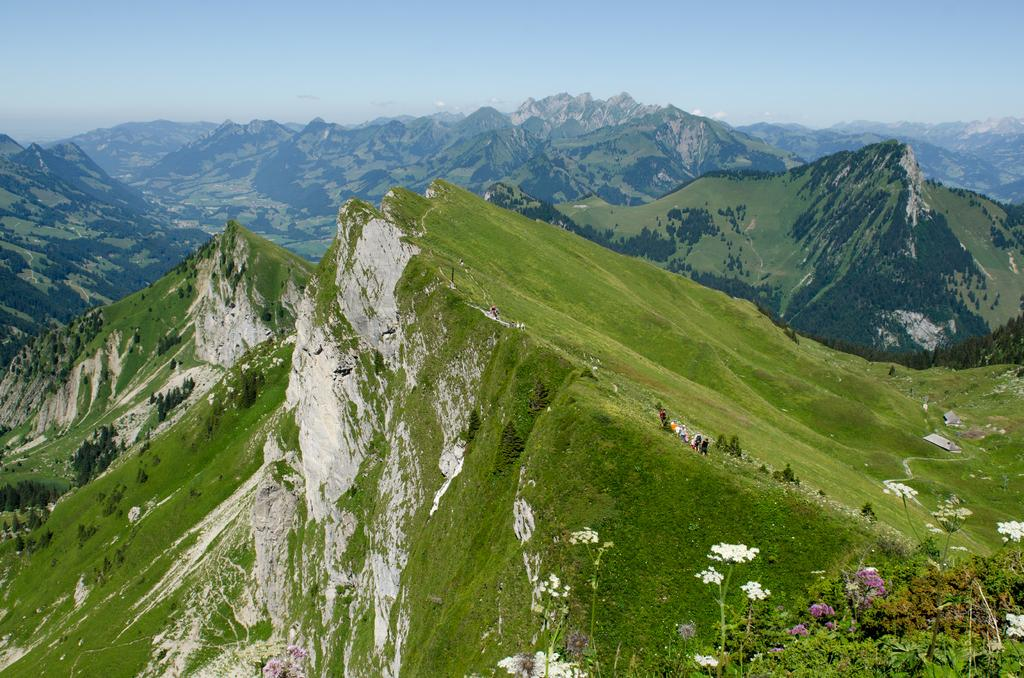What type of living organisms can be seen in the image? Plants, flowers, and trees are visible in the image. What natural landmarks are present in the image? Mountains are present in the image. Are there any human subjects in the image? Yes, there are people in the image. What can be seen in the background of the image? The sky is visible in the background of the image. What type of arithmetic problem can be solved using the jar and fruit in the image? There is no jar or fruit present in the image, so no arithmetic problem can be solved using them. 